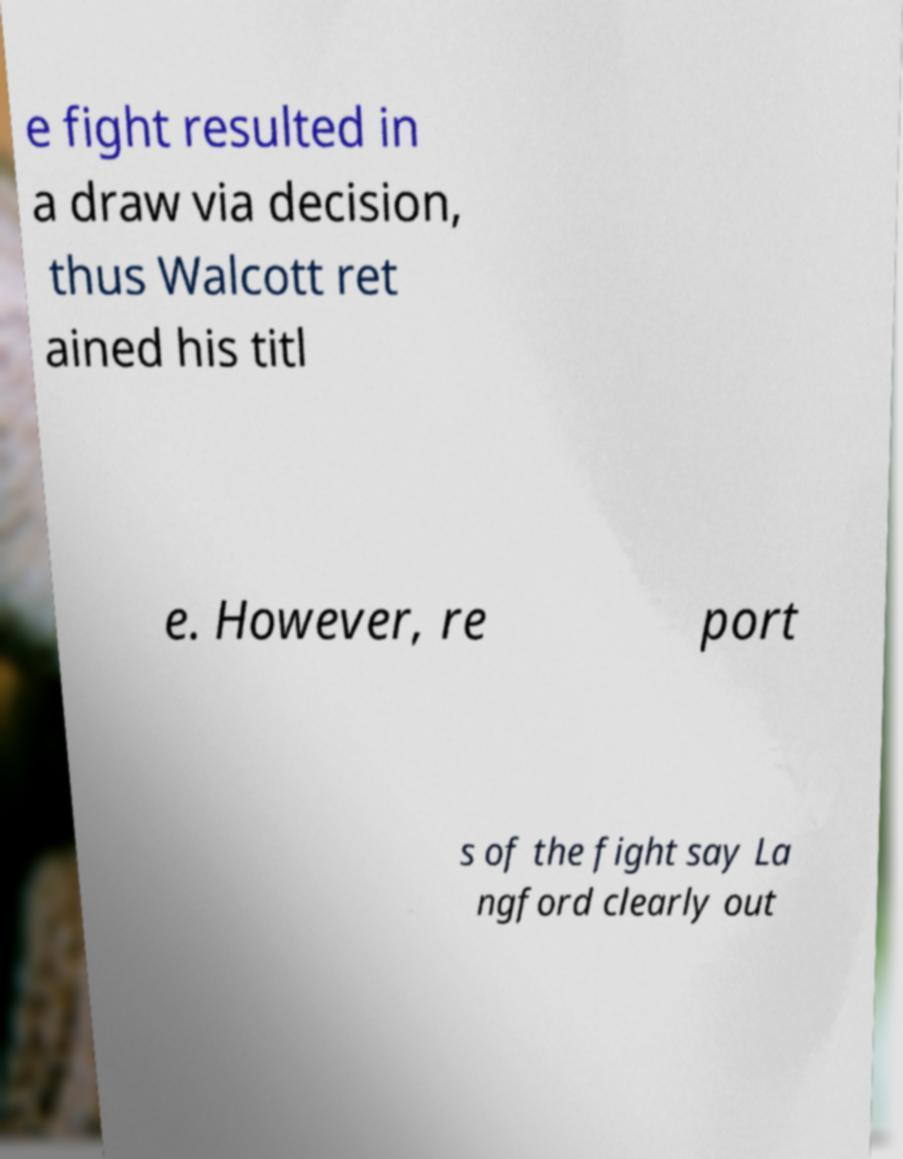Could you assist in decoding the text presented in this image and type it out clearly? e fight resulted in a draw via decision, thus Walcott ret ained his titl e. However, re port s of the fight say La ngford clearly out 